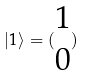Convert formula to latex. <formula><loc_0><loc_0><loc_500><loc_500>| 1 \rangle = ( \begin{matrix} 1 \\ 0 \end{matrix} )</formula> 